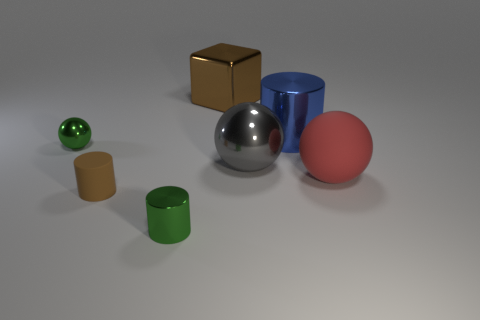Subtract all brown spheres. How many red cylinders are left? 0 Subtract all large blue objects. Subtract all big red matte balls. How many objects are left? 5 Add 5 big metallic things. How many big metallic things are left? 8 Add 1 small brown metallic cylinders. How many small brown metallic cylinders exist? 1 Add 3 blue objects. How many objects exist? 10 Subtract all red spheres. How many spheres are left? 2 Subtract all metallic cylinders. How many cylinders are left? 1 Subtract 0 cyan spheres. How many objects are left? 7 Subtract all cubes. How many objects are left? 6 Subtract 3 spheres. How many spheres are left? 0 